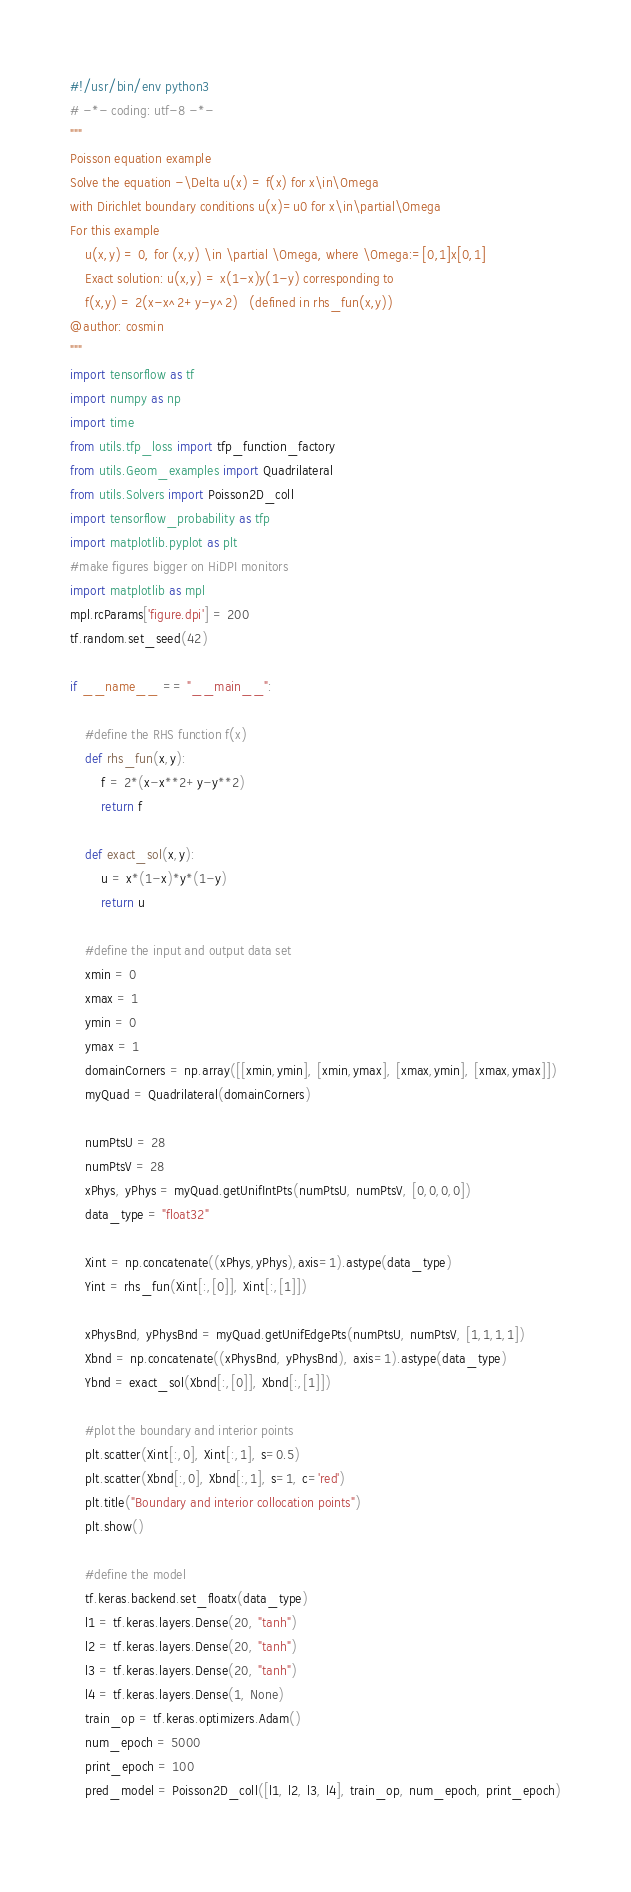Convert code to text. <code><loc_0><loc_0><loc_500><loc_500><_Python_>#!/usr/bin/env python3
# -*- coding: utf-8 -*-
"""
Poisson equation example
Solve the equation -\Delta u(x) = f(x) for x\in\Omega 
with Dirichlet boundary conditions u(x)=u0 for x\in\partial\Omega
For this example
    u(x,y) = 0, for (x,y) \in \partial \Omega, where \Omega:=[0,1]x[0,1]
    Exact solution: u(x,y) = x(1-x)y(1-y) corresponding to 
    f(x,y) = 2(x-x^2+y-y^2)   (defined in rhs_fun(x,y))
@author: cosmin
"""
import tensorflow as tf
import numpy as np
import time
from utils.tfp_loss import tfp_function_factory
from utils.Geom_examples import Quadrilateral
from utils.Solvers import Poisson2D_coll
import tensorflow_probability as tfp
import matplotlib.pyplot as plt
#make figures bigger on HiDPI monitors
import matplotlib as mpl
mpl.rcParams['figure.dpi'] = 200
tf.random.set_seed(42)

if __name__ == "__main__":
    
    #define the RHS function f(x)
    def rhs_fun(x,y):
        f = 2*(x-x**2+y-y**2)
        return f
    
    def exact_sol(x,y):
        u = x*(1-x)*y*(1-y)
        return u
        
    #define the input and output data set
    xmin = 0
    xmax = 1
    ymin = 0
    ymax = 1
    domainCorners = np.array([[xmin,ymin], [xmin,ymax], [xmax,ymin], [xmax,ymax]])
    myQuad = Quadrilateral(domainCorners)

    numPtsU = 28
    numPtsV = 28
    xPhys, yPhys = myQuad.getUnifIntPts(numPtsU, numPtsV, [0,0,0,0])
    data_type = "float32"
    
    Xint = np.concatenate((xPhys,yPhys),axis=1).astype(data_type)
    Yint = rhs_fun(Xint[:,[0]], Xint[:,[1]])
    
    xPhysBnd, yPhysBnd = myQuad.getUnifEdgePts(numPtsU, numPtsV, [1,1,1,1])
    Xbnd = np.concatenate((xPhysBnd, yPhysBnd), axis=1).astype(data_type)
    Ybnd = exact_sol(Xbnd[:,[0]], Xbnd[:,[1]])
    
    #plot the boundary and interior points
    plt.scatter(Xint[:,0], Xint[:,1], s=0.5)
    plt.scatter(Xbnd[:,0], Xbnd[:,1], s=1, c='red')
    plt.title("Boundary and interior collocation points")
    plt.show()
    
    #define the model 
    tf.keras.backend.set_floatx(data_type)
    l1 = tf.keras.layers.Dense(20, "tanh")
    l2 = tf.keras.layers.Dense(20, "tanh")
    l3 = tf.keras.layers.Dense(20, "tanh")
    l4 = tf.keras.layers.Dense(1, None)
    train_op = tf.keras.optimizers.Adam()
    num_epoch = 5000
    print_epoch = 100
    pred_model = Poisson2D_coll([l1, l2, l3, l4], train_op, num_epoch, print_epoch)
    </code> 